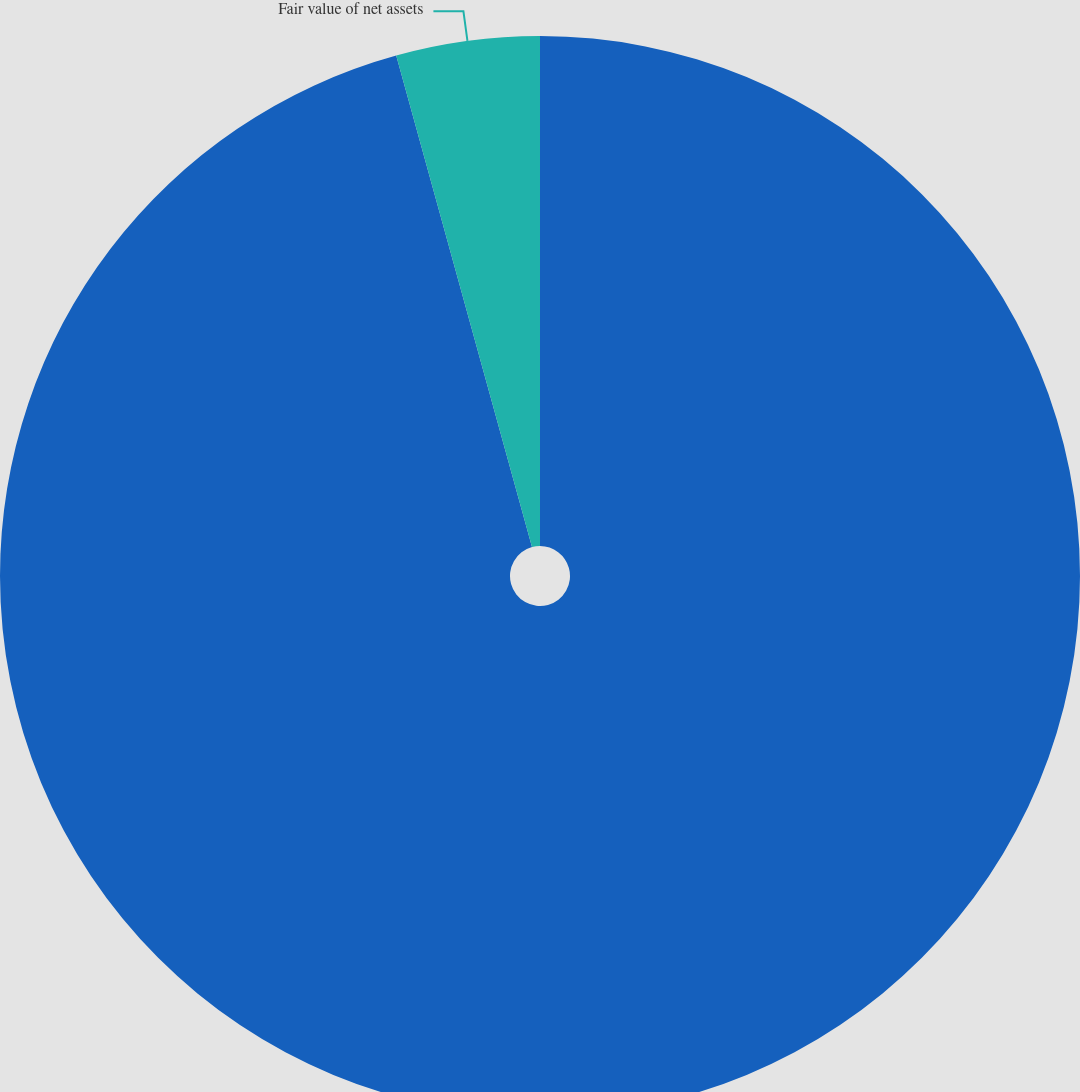Convert chart. <chart><loc_0><loc_0><loc_500><loc_500><pie_chart><fcel>(Millions of Dollars)<fcel>Fair value of net assets<nl><fcel>95.71%<fcel>4.29%<nl></chart> 